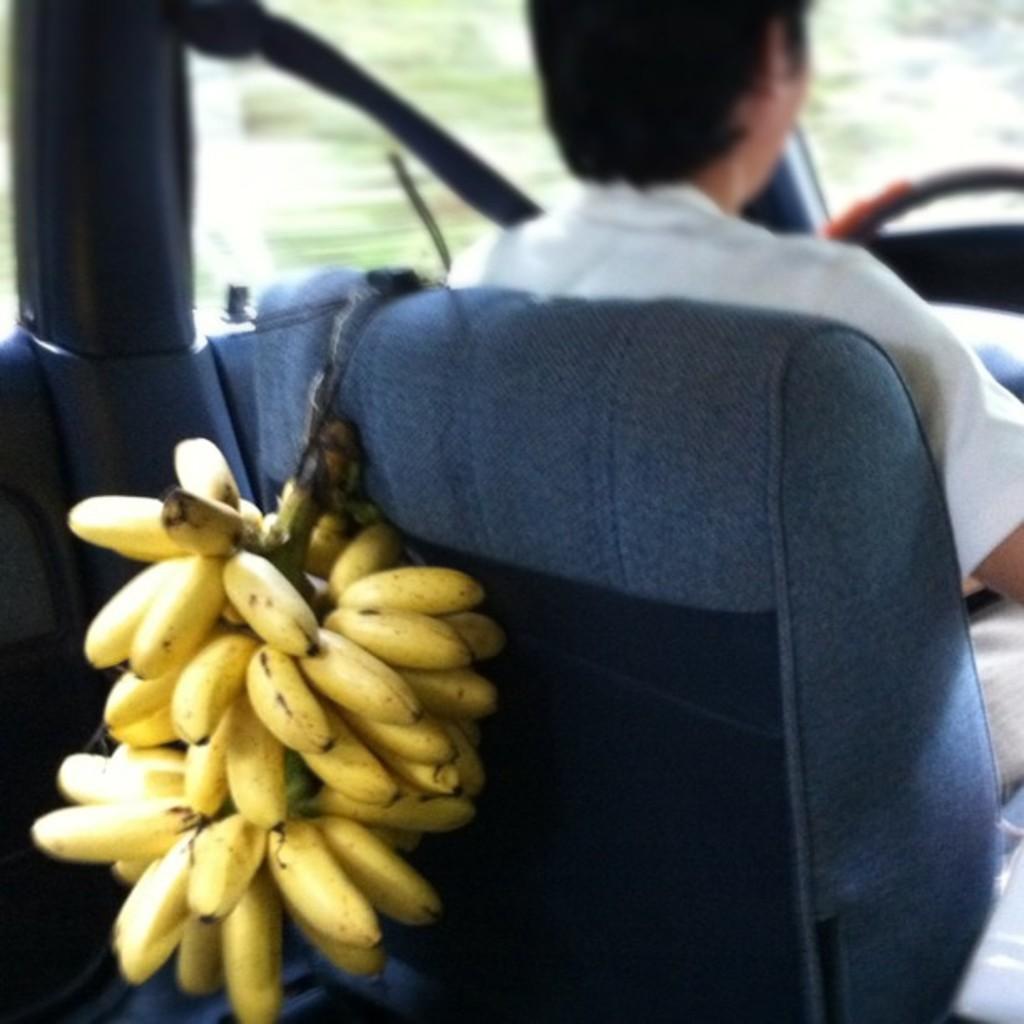Could you give a brief overview of what you see in this image? There is a person sitting on the seat. On the seat there is a bunch of banana hanged. 